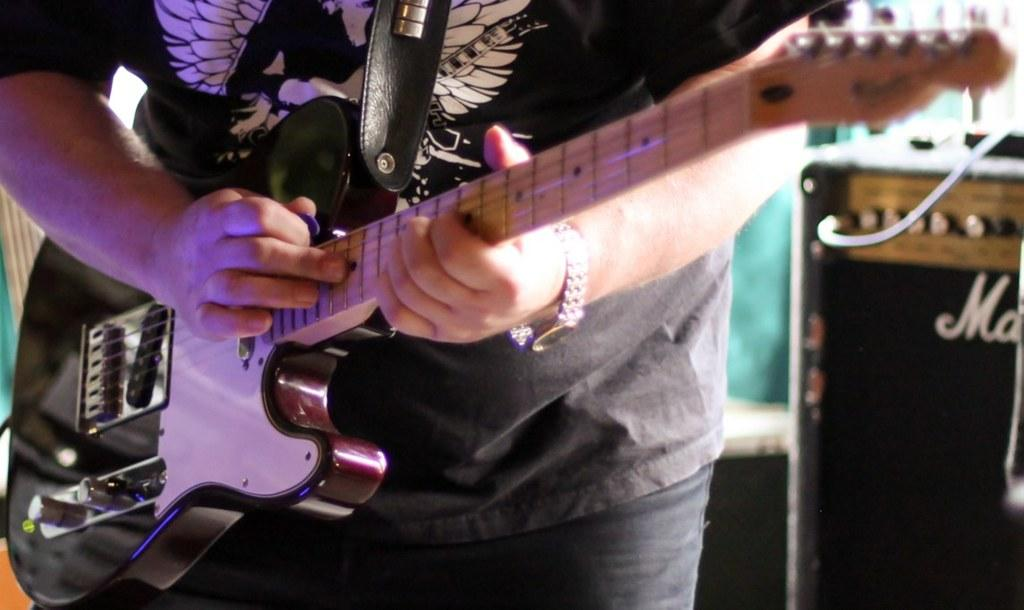Who is the main subject in the image? There is a man in the image. What is the man doing in the image? The man is standing and playing a guitar. What accessory is the man wearing in the image? The man is wearing a watch. What is the purpose of the watch? The watch is a device used for measuring time. Where is the throne located in the image? There is no throne present in the image. Can you see a snake slithering near the man's feet in the image? There is no snake present in the image. 